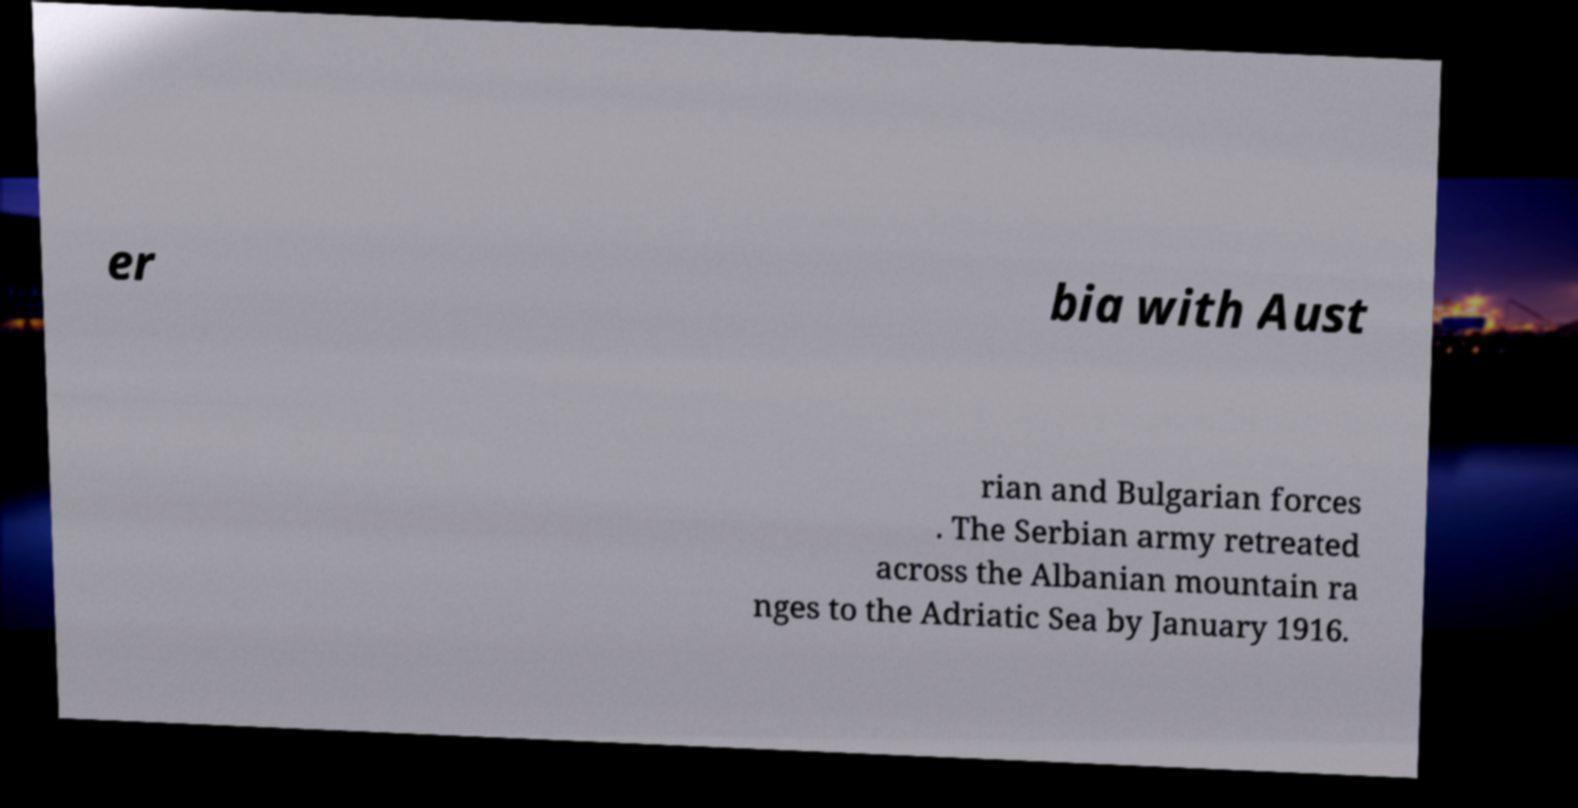There's text embedded in this image that I need extracted. Can you transcribe it verbatim? er bia with Aust rian and Bulgarian forces . The Serbian army retreated across the Albanian mountain ra nges to the Adriatic Sea by January 1916. 